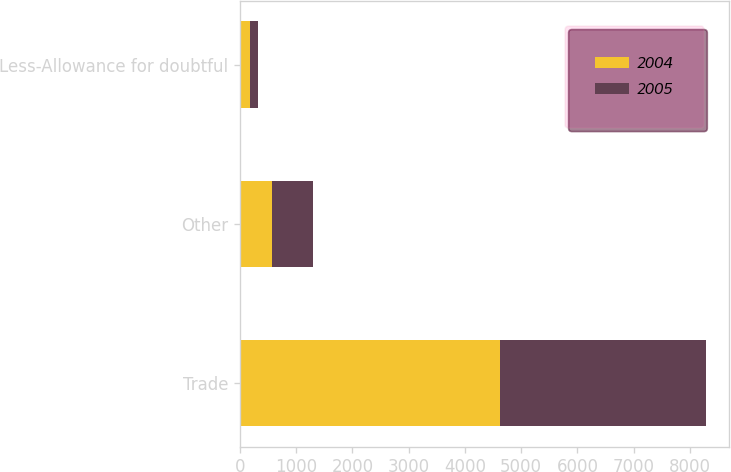<chart> <loc_0><loc_0><loc_500><loc_500><stacked_bar_chart><ecel><fcel>Trade<fcel>Other<fcel>Less-Allowance for doubtful<nl><fcel>2004<fcel>4623<fcel>573<fcel>179<nl><fcel>2005<fcel>3656<fcel>724<fcel>137<nl></chart> 